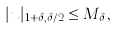<formula> <loc_0><loc_0><loc_500><loc_500>| u | _ { 1 + \delta , \delta / 2 } \leq M _ { \delta } ,</formula> 